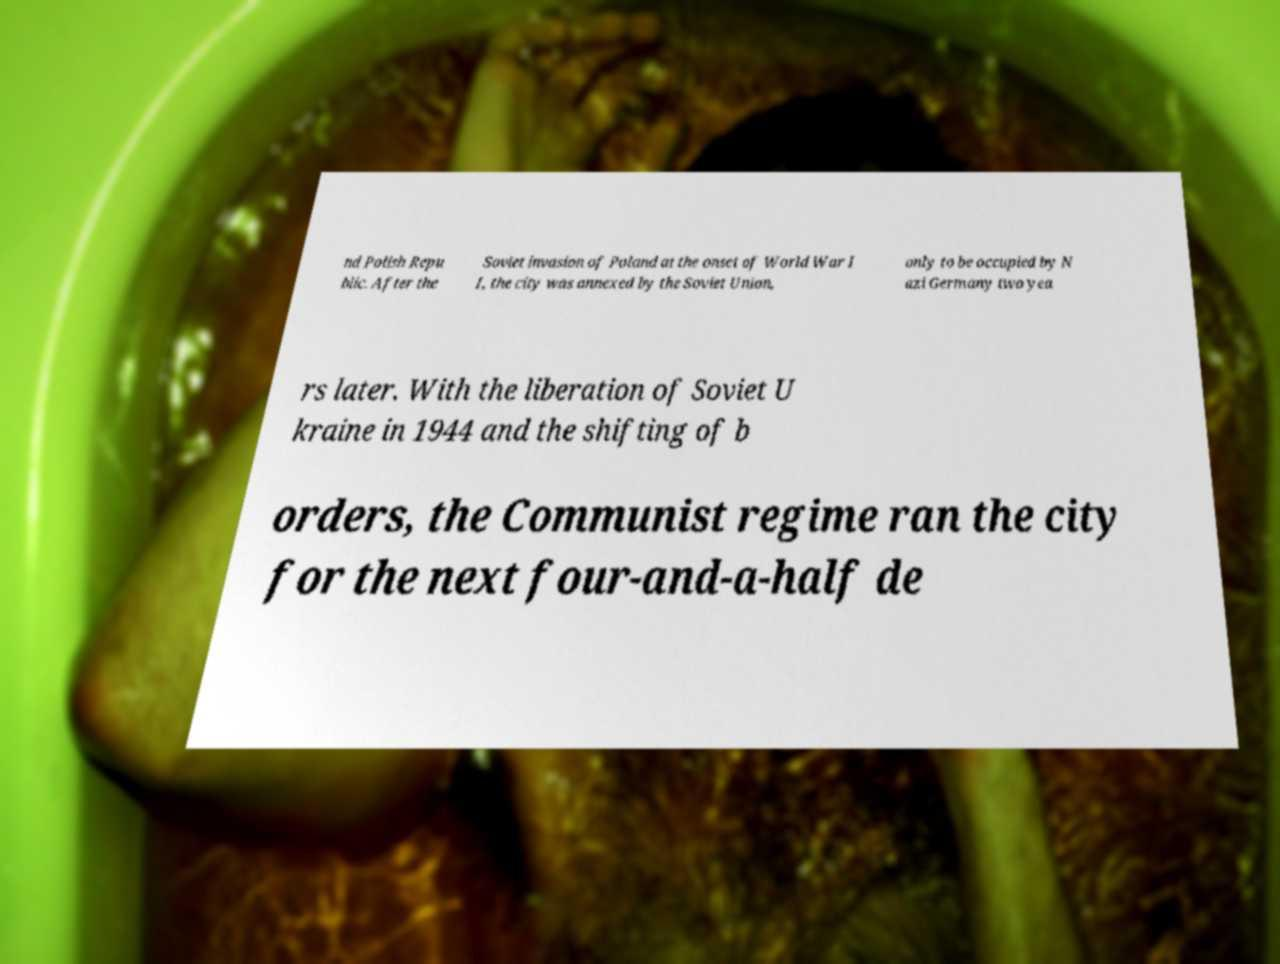Could you assist in decoding the text presented in this image and type it out clearly? nd Polish Repu blic. After the Soviet invasion of Poland at the onset of World War I I, the city was annexed by the Soviet Union, only to be occupied by N azi Germany two yea rs later. With the liberation of Soviet U kraine in 1944 and the shifting of b orders, the Communist regime ran the city for the next four-and-a-half de 